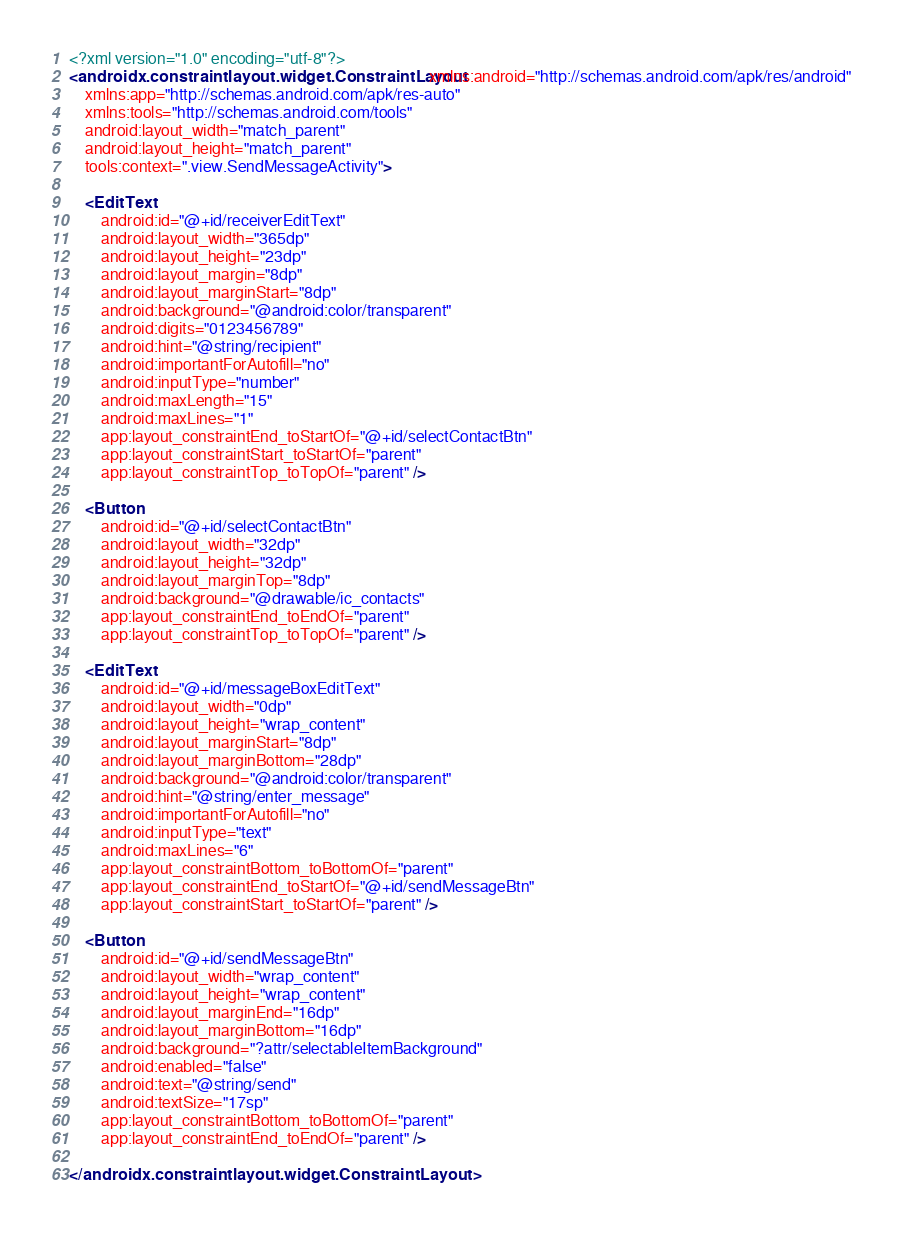<code> <loc_0><loc_0><loc_500><loc_500><_XML_><?xml version="1.0" encoding="utf-8"?>
<androidx.constraintlayout.widget.ConstraintLayout xmlns:android="http://schemas.android.com/apk/res/android"
    xmlns:app="http://schemas.android.com/apk/res-auto"
    xmlns:tools="http://schemas.android.com/tools"
    android:layout_width="match_parent"
    android:layout_height="match_parent"
    tools:context=".view.SendMessageActivity">

    <EditText
        android:id="@+id/receiverEditText"
        android:layout_width="365dp"
        android:layout_height="23dp"
        android:layout_margin="8dp"
        android:layout_marginStart="8dp"
        android:background="@android:color/transparent"
        android:digits="0123456789"
        android:hint="@string/recipient"
        android:importantForAutofill="no"
        android:inputType="number"
        android:maxLength="15"
        android:maxLines="1"
        app:layout_constraintEnd_toStartOf="@+id/selectContactBtn"
        app:layout_constraintStart_toStartOf="parent"
        app:layout_constraintTop_toTopOf="parent" />

    <Button
        android:id="@+id/selectContactBtn"
        android:layout_width="32dp"
        android:layout_height="32dp"
        android:layout_marginTop="8dp"
        android:background="@drawable/ic_contacts"
        app:layout_constraintEnd_toEndOf="parent"
        app:layout_constraintTop_toTopOf="parent" />

    <EditText
        android:id="@+id/messageBoxEditText"
        android:layout_width="0dp"
        android:layout_height="wrap_content"
        android:layout_marginStart="8dp"
        android:layout_marginBottom="28dp"
        android:background="@android:color/transparent"
        android:hint="@string/enter_message"
        android:importantForAutofill="no"
        android:inputType="text"
        android:maxLines="6"
        app:layout_constraintBottom_toBottomOf="parent"
        app:layout_constraintEnd_toStartOf="@+id/sendMessageBtn"
        app:layout_constraintStart_toStartOf="parent" />

    <Button
        android:id="@+id/sendMessageBtn"
        android:layout_width="wrap_content"
        android:layout_height="wrap_content"
        android:layout_marginEnd="16dp"
        android:layout_marginBottom="16dp"
        android:background="?attr/selectableItemBackground"
        android:enabled="false"
        android:text="@string/send"
        android:textSize="17sp"
        app:layout_constraintBottom_toBottomOf="parent"
        app:layout_constraintEnd_toEndOf="parent" />

</androidx.constraintlayout.widget.ConstraintLayout></code> 